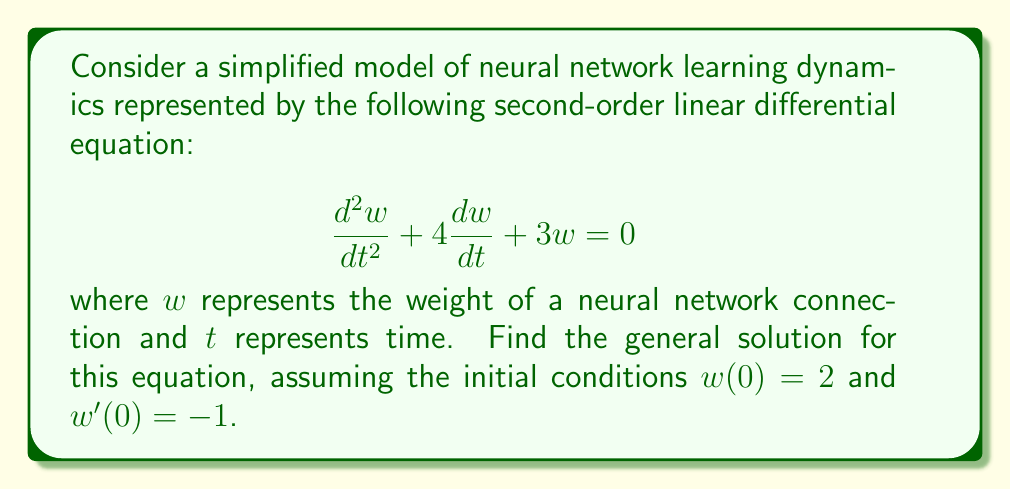Help me with this question. To solve this second-order linear differential equation, we'll follow these steps:

1) First, we need to find the characteristic equation. For a differential equation in the form $ay'' + by' + cy = 0$, the characteristic equation is $ar^2 + br + c = 0$. In our case:

   $$r^2 + 4r + 3 = 0$$

2) Solve the characteristic equation:
   $$(r + 1)(r + 3) = 0$$
   $$r = -1 \text{ or } r = -3$$

3) The general solution for distinct real roots is:
   $$w(t) = c_1e^{r_1t} + c_2e^{r_2t}$$
   
   Therefore, our general solution is:
   $$w(t) = c_1e^{-t} + c_2e^{-3t}$$

4) To find $c_1$ and $c_2$, we use the initial conditions:

   For $w(0) = 2$:
   $$2 = c_1 + c_2$$

   For $w'(0) = -1$, we first differentiate $w(t)$:
   $$w'(t) = -c_1e^{-t} - 3c_2e^{-3t}$$
   Then apply the condition:
   $$-1 = -c_1 - 3c_2$$

5) We now have a system of equations:
   $$c_1 + c_2 = 2$$
   $$c_1 + 3c_2 = 1$$

6) Solving this system:
   Subtract the first equation from the second:
   $$2c_2 = -1$$
   $$c_2 = -\frac{1}{2}$$
   
   Substitute back into the first equation:
   $$c_1 - \frac{1}{2} = 2$$
   $$c_1 = \frac{5}{2}$$

7) Therefore, the particular solution is:
   $$w(t) = \frac{5}{2}e^{-t} - \frac{1}{2}e^{-3t}$$
Answer: $$w(t) = \frac{5}{2}e^{-t} - \frac{1}{2}e^{-3t}$$ 